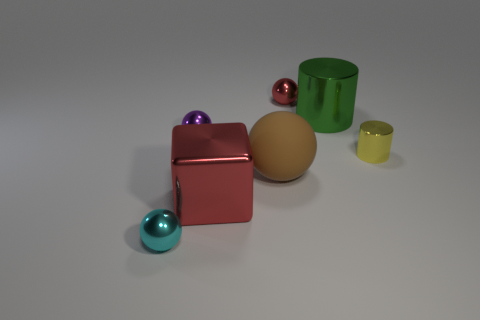Add 1 yellow metal objects. How many objects exist? 8 Subtract all tiny purple balls. How many balls are left? 3 Subtract all yellow cylinders. How many cylinders are left? 1 Subtract all yellow cylinders. Subtract all red cubes. How many cylinders are left? 1 Subtract all blue spheres. How many cyan blocks are left? 0 Subtract all yellow rubber balls. Subtract all small purple metallic spheres. How many objects are left? 6 Add 6 brown matte objects. How many brown matte objects are left? 7 Add 7 tiny yellow metal spheres. How many tiny yellow metal spheres exist? 7 Subtract 0 cyan cylinders. How many objects are left? 7 Subtract all cylinders. How many objects are left? 5 